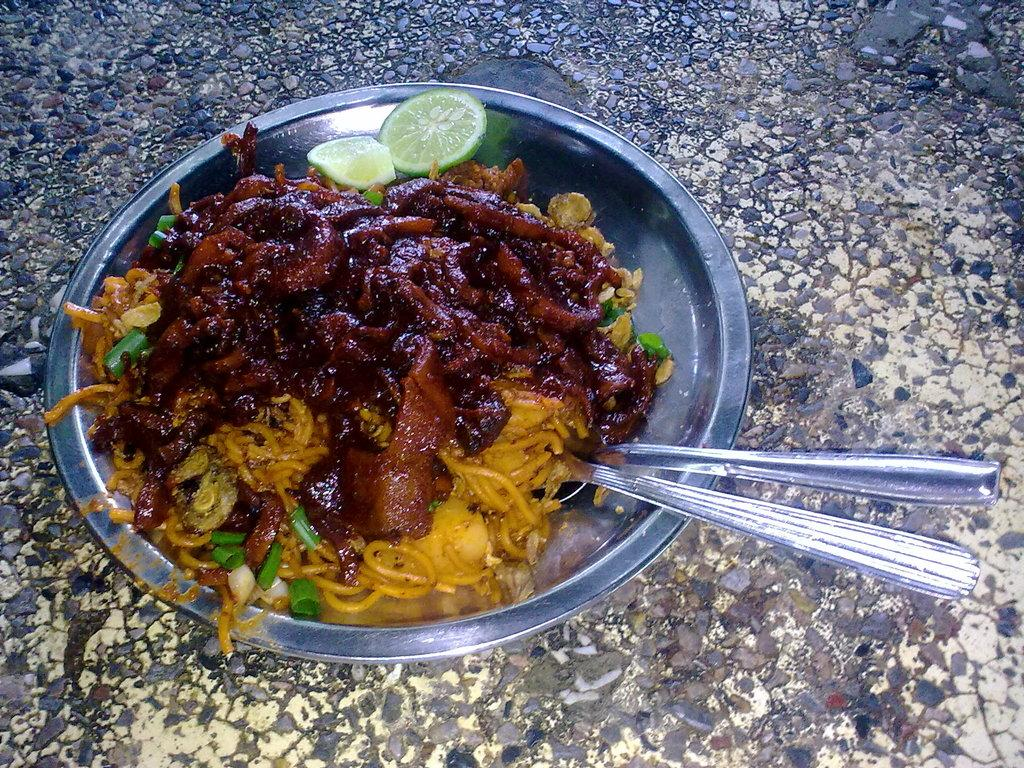What is on the plate that is visible in the image? There is a plate with food in the image. What type of food can be seen on the plate? There are pieces of lemon on the plate. What utensils are present in the image? There are spoons on the surface. What emotion does the creator of the food in the image express? The image does not show the creator of the food, so it is not possible to determine their emotions. 